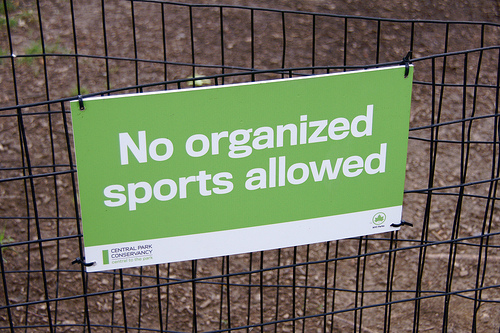<image>
Can you confirm if the sign is behind the fence? No. The sign is not behind the fence. From this viewpoint, the sign appears to be positioned elsewhere in the scene. 